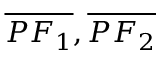<formula> <loc_0><loc_0><loc_500><loc_500>{ \overline { { P F _ { 1 } } } } , { \overline { { P F _ { 2 } } } }</formula> 